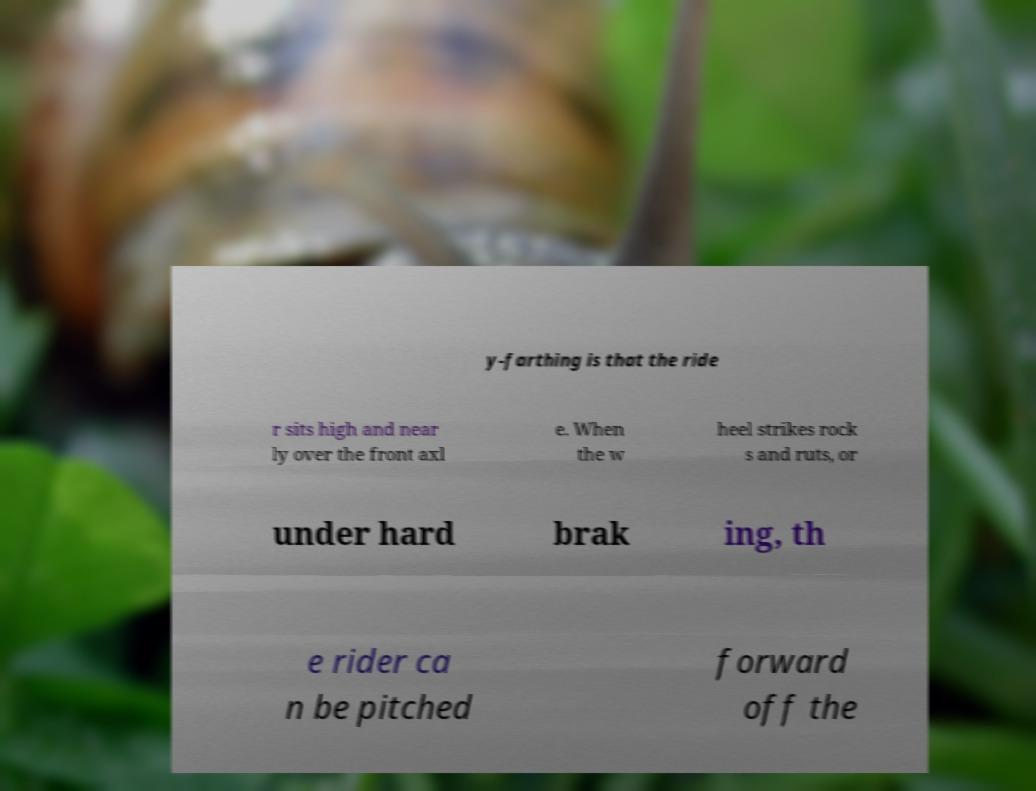Please read and relay the text visible in this image. What does it say? y-farthing is that the ride r sits high and near ly over the front axl e. When the w heel strikes rock s and ruts, or under hard brak ing, th e rider ca n be pitched forward off the 